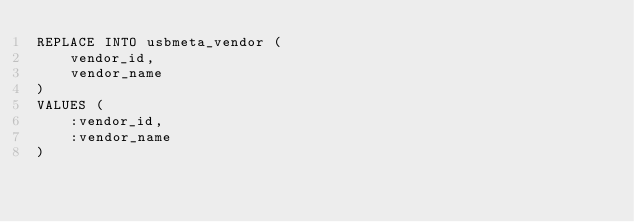Convert code to text. <code><loc_0><loc_0><loc_500><loc_500><_SQL_>REPLACE INTO usbmeta_vendor (
	vendor_id,
	vendor_name
)
VALUES (
	:vendor_id,
	:vendor_name
)
</code> 